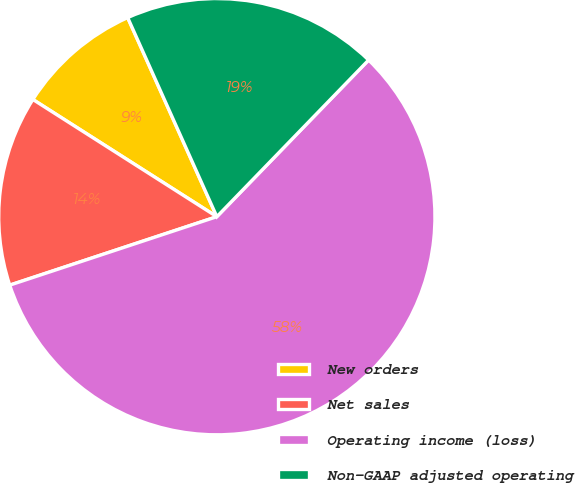<chart> <loc_0><loc_0><loc_500><loc_500><pie_chart><fcel>New orders<fcel>Net sales<fcel>Operating income (loss)<fcel>Non-GAAP adjusted operating<nl><fcel>9.27%<fcel>14.11%<fcel>57.67%<fcel>18.95%<nl></chart> 